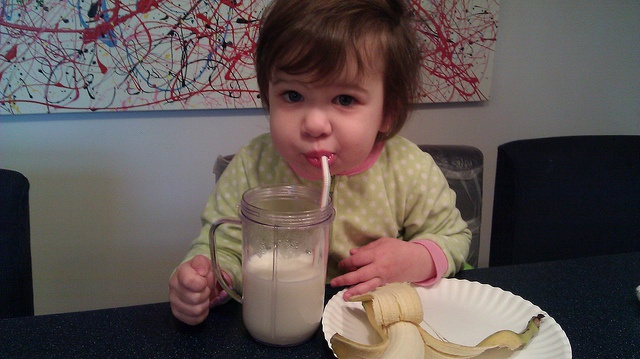Describe the objects in this image and their specific colors. I can see people in gray, black, brown, maroon, and tan tones, dining table in gray, black, tan, and lightgray tones, chair in gray and black tones, cup in gray and darkgray tones, and banana in gray and tan tones in this image. 